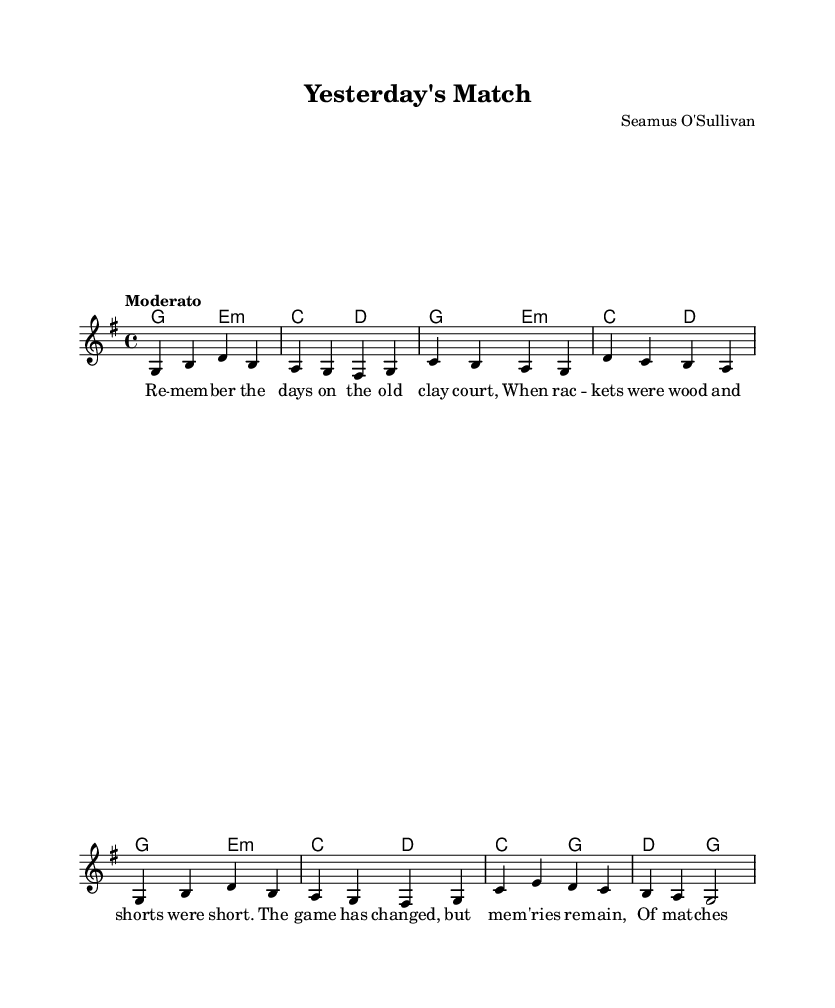What is the key signature of this music? The key signature is G major, which has one sharp (F#). This can be identified by looking at the key signature indicated at the beginning of the music on the staff.
Answer: G major What is the time signature of this music? The time signature is 4/4, which is displayed at the beginning of the piece. This indicates that there are four beats per measure and a quarter note receives one beat.
Answer: 4/4 What is the tempo marking used in this piece? The tempo marking is "Moderato," which indicates a moderate pace. This is given at the beginning of the score.
Answer: Moderato How many measures are in the melody section? There are 8 measures in the melody section. This can be calculated by counting the individual measure bars in the melody part of the sheet music.
Answer: 8 What is the first note of the melody? The first note of the melody is G. The note can be identified as the first note in the relative melody line after the clef.
Answer: G How many chord changes are in the first verse? There are 8 chord changes in the first verse. This is determined by counting the different chords indicated above the lyrics in the verse section of the sheet music.
Answer: 8 What instrument is typically associated with this type of music? This type of music is typically associated with the piano. The arrangement and chord structure suggest that piano is a primary instrument for nostalgic pop hits.
Answer: Piano 